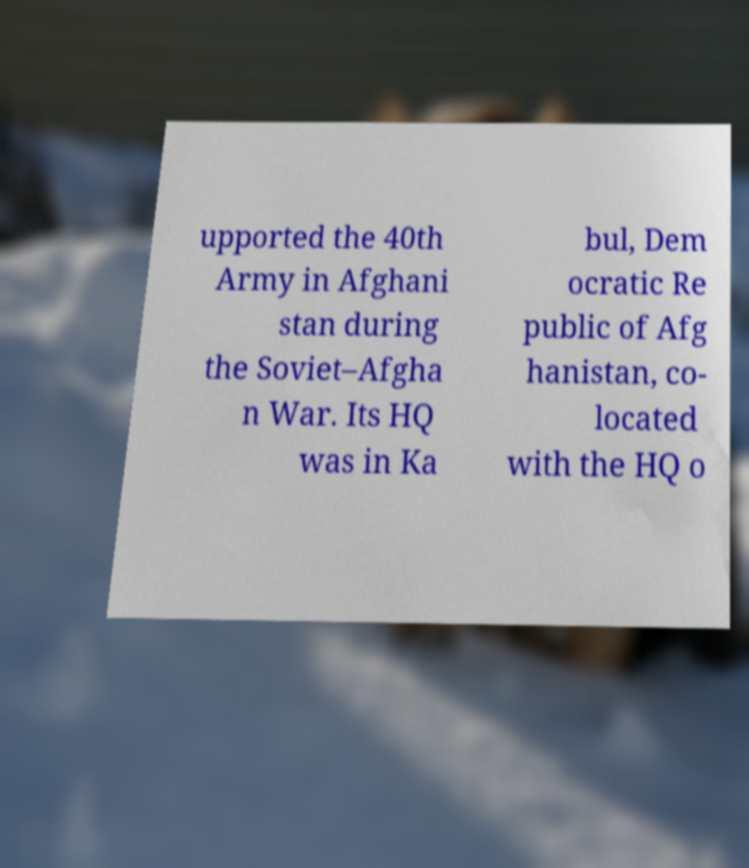For documentation purposes, I need the text within this image transcribed. Could you provide that? upported the 40th Army in Afghani stan during the Soviet–Afgha n War. Its HQ was in Ka bul, Dem ocratic Re public of Afg hanistan, co- located with the HQ o 